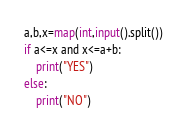<code> <loc_0><loc_0><loc_500><loc_500><_Python_>a,b,x=map(int,input().split())
if a<=x and x<=a+b:
    print("YES")
else:
    print("NO")</code> 